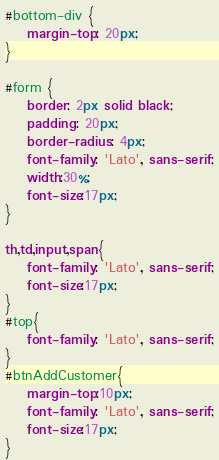<code> <loc_0><loc_0><loc_500><loc_500><_CSS_>#bottom-div {
	margin-top: 20px;
}

#form {
	border: 2px solid black;
	padding: 20px;
	border-radius: 4px;
	font-family: 'Lato', sans-serif;
	width:30%;
	font-size:17px;
}

th,td,input,span{
	font-family: 'Lato', sans-serif;
	font-size:17px;
}
#top{
	font-family: 'Lato', sans-serif;
}
#btnAddCustomer{
	margin-top:10px;
	font-family: 'Lato', sans-serif;
	font-size:17px;
}</code> 